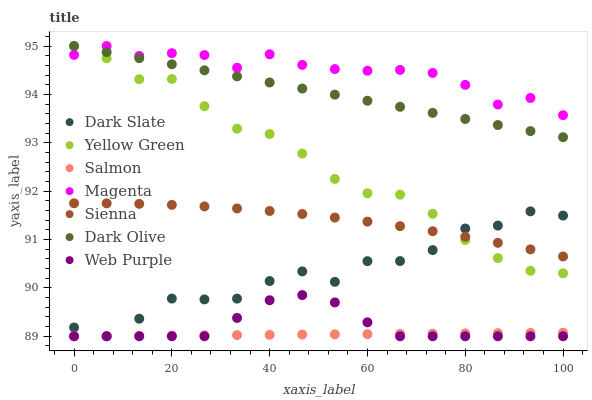Does Salmon have the minimum area under the curve?
Answer yes or no. Yes. Does Magenta have the maximum area under the curve?
Answer yes or no. Yes. Does Dark Olive have the minimum area under the curve?
Answer yes or no. No. Does Dark Olive have the maximum area under the curve?
Answer yes or no. No. Is Salmon the smoothest?
Answer yes or no. Yes. Is Dark Slate the roughest?
Answer yes or no. Yes. Is Dark Olive the smoothest?
Answer yes or no. No. Is Dark Olive the roughest?
Answer yes or no. No. Does Salmon have the lowest value?
Answer yes or no. Yes. Does Dark Olive have the lowest value?
Answer yes or no. No. Does Magenta have the highest value?
Answer yes or no. Yes. Does Salmon have the highest value?
Answer yes or no. No. Is Sienna less than Magenta?
Answer yes or no. Yes. Is Yellow Green greater than Salmon?
Answer yes or no. Yes. Does Yellow Green intersect Dark Slate?
Answer yes or no. Yes. Is Yellow Green less than Dark Slate?
Answer yes or no. No. Is Yellow Green greater than Dark Slate?
Answer yes or no. No. Does Sienna intersect Magenta?
Answer yes or no. No. 